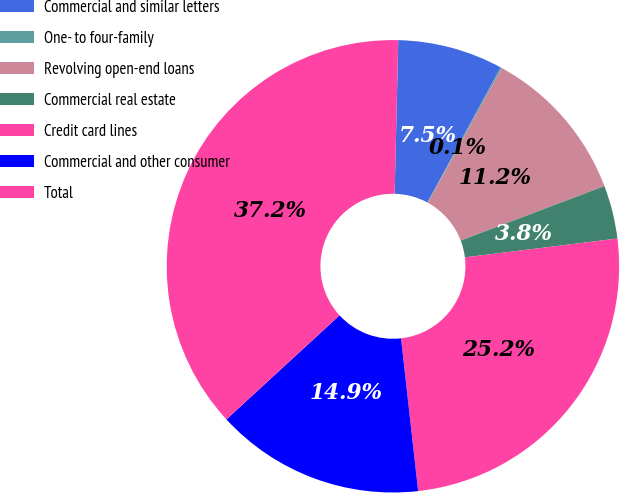Convert chart to OTSL. <chart><loc_0><loc_0><loc_500><loc_500><pie_chart><fcel>Commercial and similar letters<fcel>One- to four-family<fcel>Revolving open-end loans<fcel>Commercial real estate<fcel>Credit card lines<fcel>Commercial and other consumer<fcel>Total<nl><fcel>7.52%<fcel>0.1%<fcel>11.23%<fcel>3.81%<fcel>25.17%<fcel>14.94%<fcel>37.2%<nl></chart> 